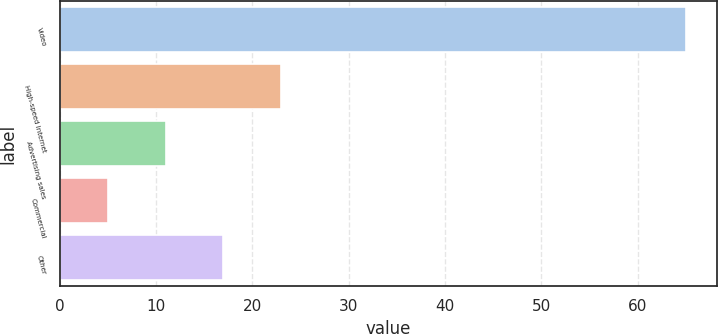<chart> <loc_0><loc_0><loc_500><loc_500><bar_chart><fcel>Video<fcel>High-speed Internet<fcel>Advertising sales<fcel>Commercial<fcel>Other<nl><fcel>65<fcel>23<fcel>11<fcel>5<fcel>17<nl></chart> 